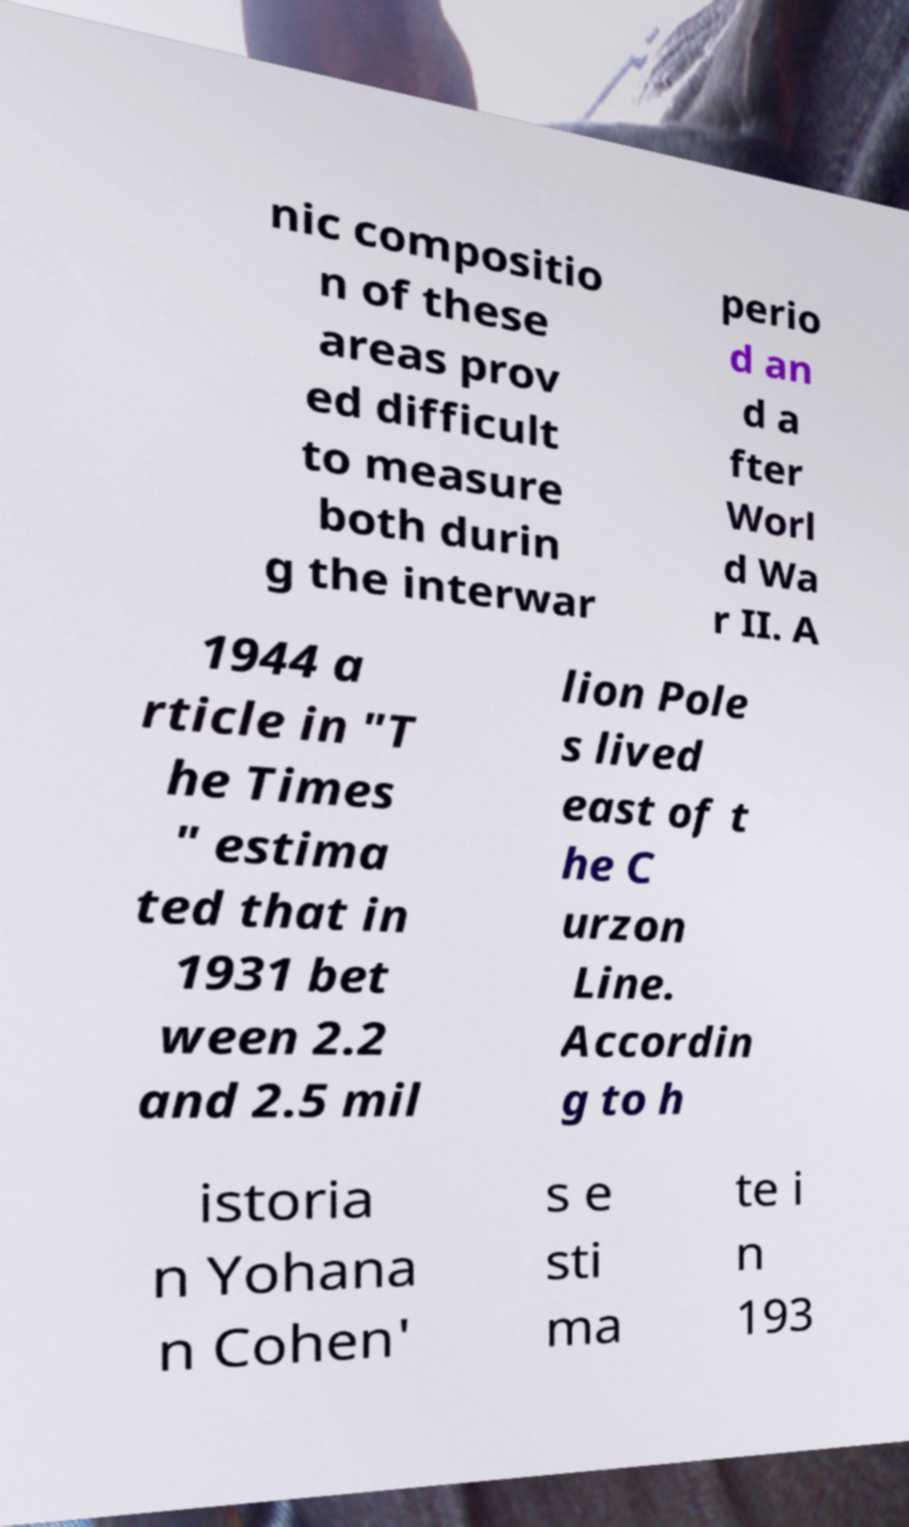Can you accurately transcribe the text from the provided image for me? nic compositio n of these areas prov ed difficult to measure both durin g the interwar perio d an d a fter Worl d Wa r II. A 1944 a rticle in "T he Times " estima ted that in 1931 bet ween 2.2 and 2.5 mil lion Pole s lived east of t he C urzon Line. Accordin g to h istoria n Yohana n Cohen' s e sti ma te i n 193 